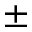<formula> <loc_0><loc_0><loc_500><loc_500>\pm</formula> 